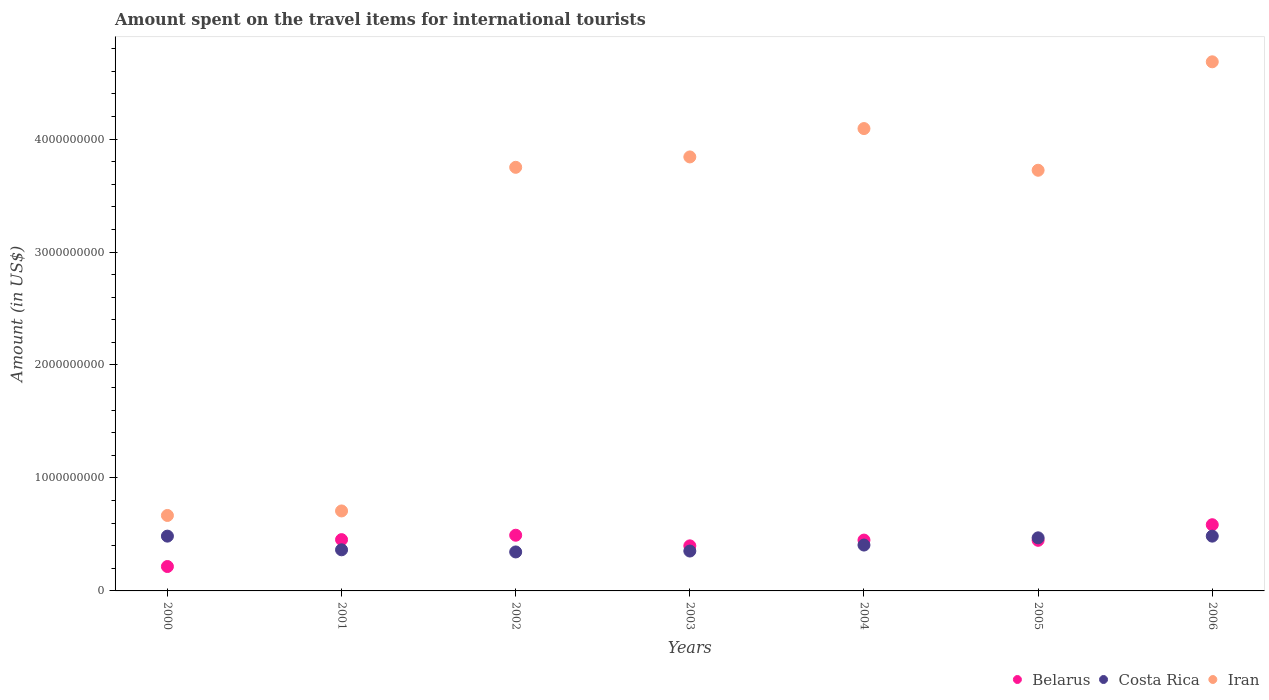How many different coloured dotlines are there?
Keep it short and to the point. 3. What is the amount spent on the travel items for international tourists in Belarus in 2006?
Ensure brevity in your answer.  5.86e+08. Across all years, what is the maximum amount spent on the travel items for international tourists in Belarus?
Your answer should be very brief. 5.86e+08. Across all years, what is the minimum amount spent on the travel items for international tourists in Belarus?
Give a very brief answer. 2.16e+08. In which year was the amount spent on the travel items for international tourists in Iran minimum?
Give a very brief answer. 2000. What is the total amount spent on the travel items for international tourists in Belarus in the graph?
Make the answer very short. 3.05e+09. What is the difference between the amount spent on the travel items for international tourists in Belarus in 2002 and that in 2004?
Offer a terse response. 4.30e+07. What is the difference between the amount spent on the travel items for international tourists in Iran in 2004 and the amount spent on the travel items for international tourists in Belarus in 2002?
Offer a terse response. 3.60e+09. What is the average amount spent on the travel items for international tourists in Costa Rica per year?
Keep it short and to the point. 4.15e+08. In the year 2002, what is the difference between the amount spent on the travel items for international tourists in Belarus and amount spent on the travel items for international tourists in Costa Rica?
Make the answer very short. 1.48e+08. In how many years, is the amount spent on the travel items for international tourists in Costa Rica greater than 2200000000 US$?
Your answer should be very brief. 0. What is the ratio of the amount spent on the travel items for international tourists in Costa Rica in 2001 to that in 2005?
Provide a succinct answer. 0.77. Is the difference between the amount spent on the travel items for international tourists in Belarus in 2000 and 2006 greater than the difference between the amount spent on the travel items for international tourists in Costa Rica in 2000 and 2006?
Make the answer very short. No. What is the difference between the highest and the second highest amount spent on the travel items for international tourists in Iran?
Keep it short and to the point. 5.91e+08. What is the difference between the highest and the lowest amount spent on the travel items for international tourists in Belarus?
Provide a succinct answer. 3.70e+08. In how many years, is the amount spent on the travel items for international tourists in Iran greater than the average amount spent on the travel items for international tourists in Iran taken over all years?
Provide a succinct answer. 5. Is the amount spent on the travel items for international tourists in Belarus strictly greater than the amount spent on the travel items for international tourists in Iran over the years?
Ensure brevity in your answer.  No. Is the amount spent on the travel items for international tourists in Belarus strictly less than the amount spent on the travel items for international tourists in Costa Rica over the years?
Provide a succinct answer. No. How many dotlines are there?
Offer a terse response. 3. What is the difference between two consecutive major ticks on the Y-axis?
Your answer should be very brief. 1.00e+09. Are the values on the major ticks of Y-axis written in scientific E-notation?
Provide a short and direct response. No. Does the graph contain any zero values?
Your response must be concise. No. Does the graph contain grids?
Give a very brief answer. No. How many legend labels are there?
Your answer should be very brief. 3. What is the title of the graph?
Provide a succinct answer. Amount spent on the travel items for international tourists. What is the label or title of the Y-axis?
Provide a succinct answer. Amount (in US$). What is the Amount (in US$) in Belarus in 2000?
Your answer should be compact. 2.16e+08. What is the Amount (in US$) in Costa Rica in 2000?
Your response must be concise. 4.85e+08. What is the Amount (in US$) of Iran in 2000?
Your answer should be very brief. 6.68e+08. What is the Amount (in US$) of Belarus in 2001?
Offer a terse response. 4.54e+08. What is the Amount (in US$) of Costa Rica in 2001?
Keep it short and to the point. 3.64e+08. What is the Amount (in US$) in Iran in 2001?
Offer a terse response. 7.08e+08. What is the Amount (in US$) in Belarus in 2002?
Provide a succinct answer. 4.93e+08. What is the Amount (in US$) of Costa Rica in 2002?
Make the answer very short. 3.45e+08. What is the Amount (in US$) of Iran in 2002?
Offer a terse response. 3.75e+09. What is the Amount (in US$) of Belarus in 2003?
Your answer should be very brief. 3.99e+08. What is the Amount (in US$) in Costa Rica in 2003?
Keep it short and to the point. 3.53e+08. What is the Amount (in US$) in Iran in 2003?
Your response must be concise. 3.84e+09. What is the Amount (in US$) in Belarus in 2004?
Make the answer very short. 4.50e+08. What is the Amount (in US$) of Costa Rica in 2004?
Provide a short and direct response. 4.06e+08. What is the Amount (in US$) in Iran in 2004?
Provide a succinct answer. 4.09e+09. What is the Amount (in US$) in Belarus in 2005?
Your response must be concise. 4.48e+08. What is the Amount (in US$) of Costa Rica in 2005?
Your answer should be compact. 4.70e+08. What is the Amount (in US$) of Iran in 2005?
Keep it short and to the point. 3.72e+09. What is the Amount (in US$) in Belarus in 2006?
Give a very brief answer. 5.86e+08. What is the Amount (in US$) of Costa Rica in 2006?
Give a very brief answer. 4.85e+08. What is the Amount (in US$) in Iran in 2006?
Make the answer very short. 4.68e+09. Across all years, what is the maximum Amount (in US$) in Belarus?
Give a very brief answer. 5.86e+08. Across all years, what is the maximum Amount (in US$) of Costa Rica?
Provide a short and direct response. 4.85e+08. Across all years, what is the maximum Amount (in US$) of Iran?
Provide a short and direct response. 4.68e+09. Across all years, what is the minimum Amount (in US$) of Belarus?
Your answer should be compact. 2.16e+08. Across all years, what is the minimum Amount (in US$) of Costa Rica?
Make the answer very short. 3.45e+08. Across all years, what is the minimum Amount (in US$) of Iran?
Your answer should be very brief. 6.68e+08. What is the total Amount (in US$) of Belarus in the graph?
Ensure brevity in your answer.  3.05e+09. What is the total Amount (in US$) of Costa Rica in the graph?
Ensure brevity in your answer.  2.91e+09. What is the total Amount (in US$) in Iran in the graph?
Offer a terse response. 2.15e+1. What is the difference between the Amount (in US$) in Belarus in 2000 and that in 2001?
Your answer should be very brief. -2.38e+08. What is the difference between the Amount (in US$) of Costa Rica in 2000 and that in 2001?
Offer a very short reply. 1.21e+08. What is the difference between the Amount (in US$) in Iran in 2000 and that in 2001?
Make the answer very short. -4.00e+07. What is the difference between the Amount (in US$) in Belarus in 2000 and that in 2002?
Provide a short and direct response. -2.77e+08. What is the difference between the Amount (in US$) in Costa Rica in 2000 and that in 2002?
Your response must be concise. 1.40e+08. What is the difference between the Amount (in US$) of Iran in 2000 and that in 2002?
Offer a terse response. -3.08e+09. What is the difference between the Amount (in US$) of Belarus in 2000 and that in 2003?
Provide a succinct answer. -1.83e+08. What is the difference between the Amount (in US$) of Costa Rica in 2000 and that in 2003?
Make the answer very short. 1.32e+08. What is the difference between the Amount (in US$) of Iran in 2000 and that in 2003?
Give a very brief answer. -3.17e+09. What is the difference between the Amount (in US$) of Belarus in 2000 and that in 2004?
Give a very brief answer. -2.34e+08. What is the difference between the Amount (in US$) in Costa Rica in 2000 and that in 2004?
Give a very brief answer. 7.90e+07. What is the difference between the Amount (in US$) of Iran in 2000 and that in 2004?
Make the answer very short. -3.42e+09. What is the difference between the Amount (in US$) of Belarus in 2000 and that in 2005?
Provide a succinct answer. -2.32e+08. What is the difference between the Amount (in US$) in Costa Rica in 2000 and that in 2005?
Ensure brevity in your answer.  1.50e+07. What is the difference between the Amount (in US$) of Iran in 2000 and that in 2005?
Keep it short and to the point. -3.06e+09. What is the difference between the Amount (in US$) in Belarus in 2000 and that in 2006?
Keep it short and to the point. -3.70e+08. What is the difference between the Amount (in US$) in Costa Rica in 2000 and that in 2006?
Keep it short and to the point. 0. What is the difference between the Amount (in US$) in Iran in 2000 and that in 2006?
Offer a terse response. -4.02e+09. What is the difference between the Amount (in US$) of Belarus in 2001 and that in 2002?
Your answer should be compact. -3.90e+07. What is the difference between the Amount (in US$) of Costa Rica in 2001 and that in 2002?
Make the answer very short. 1.90e+07. What is the difference between the Amount (in US$) in Iran in 2001 and that in 2002?
Give a very brief answer. -3.04e+09. What is the difference between the Amount (in US$) of Belarus in 2001 and that in 2003?
Your answer should be very brief. 5.50e+07. What is the difference between the Amount (in US$) in Costa Rica in 2001 and that in 2003?
Keep it short and to the point. 1.10e+07. What is the difference between the Amount (in US$) of Iran in 2001 and that in 2003?
Keep it short and to the point. -3.13e+09. What is the difference between the Amount (in US$) in Costa Rica in 2001 and that in 2004?
Provide a succinct answer. -4.20e+07. What is the difference between the Amount (in US$) in Iran in 2001 and that in 2004?
Your response must be concise. -3.38e+09. What is the difference between the Amount (in US$) of Belarus in 2001 and that in 2005?
Offer a very short reply. 6.00e+06. What is the difference between the Amount (in US$) of Costa Rica in 2001 and that in 2005?
Make the answer very short. -1.06e+08. What is the difference between the Amount (in US$) in Iran in 2001 and that in 2005?
Offer a very short reply. -3.02e+09. What is the difference between the Amount (in US$) of Belarus in 2001 and that in 2006?
Offer a terse response. -1.32e+08. What is the difference between the Amount (in US$) in Costa Rica in 2001 and that in 2006?
Make the answer very short. -1.21e+08. What is the difference between the Amount (in US$) of Iran in 2001 and that in 2006?
Make the answer very short. -3.98e+09. What is the difference between the Amount (in US$) in Belarus in 2002 and that in 2003?
Provide a short and direct response. 9.40e+07. What is the difference between the Amount (in US$) in Costa Rica in 2002 and that in 2003?
Offer a terse response. -8.00e+06. What is the difference between the Amount (in US$) in Iran in 2002 and that in 2003?
Ensure brevity in your answer.  -9.20e+07. What is the difference between the Amount (in US$) in Belarus in 2002 and that in 2004?
Your answer should be compact. 4.30e+07. What is the difference between the Amount (in US$) of Costa Rica in 2002 and that in 2004?
Your answer should be very brief. -6.10e+07. What is the difference between the Amount (in US$) of Iran in 2002 and that in 2004?
Ensure brevity in your answer.  -3.43e+08. What is the difference between the Amount (in US$) of Belarus in 2002 and that in 2005?
Ensure brevity in your answer.  4.50e+07. What is the difference between the Amount (in US$) in Costa Rica in 2002 and that in 2005?
Provide a short and direct response. -1.25e+08. What is the difference between the Amount (in US$) in Iran in 2002 and that in 2005?
Your answer should be very brief. 2.60e+07. What is the difference between the Amount (in US$) of Belarus in 2002 and that in 2006?
Give a very brief answer. -9.30e+07. What is the difference between the Amount (in US$) of Costa Rica in 2002 and that in 2006?
Make the answer very short. -1.40e+08. What is the difference between the Amount (in US$) in Iran in 2002 and that in 2006?
Give a very brief answer. -9.34e+08. What is the difference between the Amount (in US$) of Belarus in 2003 and that in 2004?
Your response must be concise. -5.10e+07. What is the difference between the Amount (in US$) of Costa Rica in 2003 and that in 2004?
Your response must be concise. -5.30e+07. What is the difference between the Amount (in US$) of Iran in 2003 and that in 2004?
Provide a short and direct response. -2.51e+08. What is the difference between the Amount (in US$) in Belarus in 2003 and that in 2005?
Provide a short and direct response. -4.90e+07. What is the difference between the Amount (in US$) in Costa Rica in 2003 and that in 2005?
Provide a short and direct response. -1.17e+08. What is the difference between the Amount (in US$) in Iran in 2003 and that in 2005?
Keep it short and to the point. 1.18e+08. What is the difference between the Amount (in US$) in Belarus in 2003 and that in 2006?
Provide a succinct answer. -1.87e+08. What is the difference between the Amount (in US$) of Costa Rica in 2003 and that in 2006?
Your response must be concise. -1.32e+08. What is the difference between the Amount (in US$) in Iran in 2003 and that in 2006?
Offer a terse response. -8.42e+08. What is the difference between the Amount (in US$) in Belarus in 2004 and that in 2005?
Your response must be concise. 2.00e+06. What is the difference between the Amount (in US$) in Costa Rica in 2004 and that in 2005?
Your answer should be compact. -6.40e+07. What is the difference between the Amount (in US$) in Iran in 2004 and that in 2005?
Provide a short and direct response. 3.69e+08. What is the difference between the Amount (in US$) in Belarus in 2004 and that in 2006?
Keep it short and to the point. -1.36e+08. What is the difference between the Amount (in US$) in Costa Rica in 2004 and that in 2006?
Keep it short and to the point. -7.90e+07. What is the difference between the Amount (in US$) of Iran in 2004 and that in 2006?
Your answer should be compact. -5.91e+08. What is the difference between the Amount (in US$) of Belarus in 2005 and that in 2006?
Your answer should be compact. -1.38e+08. What is the difference between the Amount (in US$) of Costa Rica in 2005 and that in 2006?
Your answer should be very brief. -1.50e+07. What is the difference between the Amount (in US$) in Iran in 2005 and that in 2006?
Give a very brief answer. -9.60e+08. What is the difference between the Amount (in US$) of Belarus in 2000 and the Amount (in US$) of Costa Rica in 2001?
Keep it short and to the point. -1.48e+08. What is the difference between the Amount (in US$) in Belarus in 2000 and the Amount (in US$) in Iran in 2001?
Your answer should be compact. -4.92e+08. What is the difference between the Amount (in US$) of Costa Rica in 2000 and the Amount (in US$) of Iran in 2001?
Your response must be concise. -2.23e+08. What is the difference between the Amount (in US$) in Belarus in 2000 and the Amount (in US$) in Costa Rica in 2002?
Ensure brevity in your answer.  -1.29e+08. What is the difference between the Amount (in US$) of Belarus in 2000 and the Amount (in US$) of Iran in 2002?
Provide a short and direct response. -3.53e+09. What is the difference between the Amount (in US$) in Costa Rica in 2000 and the Amount (in US$) in Iran in 2002?
Offer a very short reply. -3.26e+09. What is the difference between the Amount (in US$) of Belarus in 2000 and the Amount (in US$) of Costa Rica in 2003?
Your response must be concise. -1.37e+08. What is the difference between the Amount (in US$) of Belarus in 2000 and the Amount (in US$) of Iran in 2003?
Provide a short and direct response. -3.63e+09. What is the difference between the Amount (in US$) in Costa Rica in 2000 and the Amount (in US$) in Iran in 2003?
Your answer should be compact. -3.36e+09. What is the difference between the Amount (in US$) of Belarus in 2000 and the Amount (in US$) of Costa Rica in 2004?
Your response must be concise. -1.90e+08. What is the difference between the Amount (in US$) in Belarus in 2000 and the Amount (in US$) in Iran in 2004?
Make the answer very short. -3.88e+09. What is the difference between the Amount (in US$) in Costa Rica in 2000 and the Amount (in US$) in Iran in 2004?
Make the answer very short. -3.61e+09. What is the difference between the Amount (in US$) of Belarus in 2000 and the Amount (in US$) of Costa Rica in 2005?
Your response must be concise. -2.54e+08. What is the difference between the Amount (in US$) in Belarus in 2000 and the Amount (in US$) in Iran in 2005?
Your answer should be compact. -3.51e+09. What is the difference between the Amount (in US$) in Costa Rica in 2000 and the Amount (in US$) in Iran in 2005?
Offer a terse response. -3.24e+09. What is the difference between the Amount (in US$) of Belarus in 2000 and the Amount (in US$) of Costa Rica in 2006?
Your answer should be compact. -2.69e+08. What is the difference between the Amount (in US$) of Belarus in 2000 and the Amount (in US$) of Iran in 2006?
Offer a very short reply. -4.47e+09. What is the difference between the Amount (in US$) of Costa Rica in 2000 and the Amount (in US$) of Iran in 2006?
Offer a terse response. -4.20e+09. What is the difference between the Amount (in US$) of Belarus in 2001 and the Amount (in US$) of Costa Rica in 2002?
Your answer should be compact. 1.09e+08. What is the difference between the Amount (in US$) of Belarus in 2001 and the Amount (in US$) of Iran in 2002?
Provide a succinct answer. -3.30e+09. What is the difference between the Amount (in US$) of Costa Rica in 2001 and the Amount (in US$) of Iran in 2002?
Keep it short and to the point. -3.39e+09. What is the difference between the Amount (in US$) in Belarus in 2001 and the Amount (in US$) in Costa Rica in 2003?
Provide a succinct answer. 1.01e+08. What is the difference between the Amount (in US$) in Belarus in 2001 and the Amount (in US$) in Iran in 2003?
Give a very brief answer. -3.39e+09. What is the difference between the Amount (in US$) in Costa Rica in 2001 and the Amount (in US$) in Iran in 2003?
Keep it short and to the point. -3.48e+09. What is the difference between the Amount (in US$) of Belarus in 2001 and the Amount (in US$) of Costa Rica in 2004?
Provide a short and direct response. 4.80e+07. What is the difference between the Amount (in US$) in Belarus in 2001 and the Amount (in US$) in Iran in 2004?
Give a very brief answer. -3.64e+09. What is the difference between the Amount (in US$) of Costa Rica in 2001 and the Amount (in US$) of Iran in 2004?
Your answer should be compact. -3.73e+09. What is the difference between the Amount (in US$) of Belarus in 2001 and the Amount (in US$) of Costa Rica in 2005?
Provide a short and direct response. -1.60e+07. What is the difference between the Amount (in US$) in Belarus in 2001 and the Amount (in US$) in Iran in 2005?
Give a very brief answer. -3.27e+09. What is the difference between the Amount (in US$) in Costa Rica in 2001 and the Amount (in US$) in Iran in 2005?
Make the answer very short. -3.36e+09. What is the difference between the Amount (in US$) in Belarus in 2001 and the Amount (in US$) in Costa Rica in 2006?
Your response must be concise. -3.10e+07. What is the difference between the Amount (in US$) in Belarus in 2001 and the Amount (in US$) in Iran in 2006?
Provide a short and direct response. -4.23e+09. What is the difference between the Amount (in US$) of Costa Rica in 2001 and the Amount (in US$) of Iran in 2006?
Provide a short and direct response. -4.32e+09. What is the difference between the Amount (in US$) of Belarus in 2002 and the Amount (in US$) of Costa Rica in 2003?
Your response must be concise. 1.40e+08. What is the difference between the Amount (in US$) in Belarus in 2002 and the Amount (in US$) in Iran in 2003?
Give a very brief answer. -3.35e+09. What is the difference between the Amount (in US$) in Costa Rica in 2002 and the Amount (in US$) in Iran in 2003?
Offer a terse response. -3.50e+09. What is the difference between the Amount (in US$) in Belarus in 2002 and the Amount (in US$) in Costa Rica in 2004?
Keep it short and to the point. 8.70e+07. What is the difference between the Amount (in US$) in Belarus in 2002 and the Amount (in US$) in Iran in 2004?
Your response must be concise. -3.60e+09. What is the difference between the Amount (in US$) in Costa Rica in 2002 and the Amount (in US$) in Iran in 2004?
Ensure brevity in your answer.  -3.75e+09. What is the difference between the Amount (in US$) in Belarus in 2002 and the Amount (in US$) in Costa Rica in 2005?
Make the answer very short. 2.30e+07. What is the difference between the Amount (in US$) of Belarus in 2002 and the Amount (in US$) of Iran in 2005?
Give a very brief answer. -3.23e+09. What is the difference between the Amount (in US$) of Costa Rica in 2002 and the Amount (in US$) of Iran in 2005?
Provide a short and direct response. -3.38e+09. What is the difference between the Amount (in US$) in Belarus in 2002 and the Amount (in US$) in Costa Rica in 2006?
Offer a very short reply. 8.00e+06. What is the difference between the Amount (in US$) of Belarus in 2002 and the Amount (in US$) of Iran in 2006?
Provide a short and direct response. -4.19e+09. What is the difference between the Amount (in US$) of Costa Rica in 2002 and the Amount (in US$) of Iran in 2006?
Provide a succinct answer. -4.34e+09. What is the difference between the Amount (in US$) of Belarus in 2003 and the Amount (in US$) of Costa Rica in 2004?
Your answer should be very brief. -7.00e+06. What is the difference between the Amount (in US$) in Belarus in 2003 and the Amount (in US$) in Iran in 2004?
Offer a very short reply. -3.69e+09. What is the difference between the Amount (in US$) of Costa Rica in 2003 and the Amount (in US$) of Iran in 2004?
Your response must be concise. -3.74e+09. What is the difference between the Amount (in US$) of Belarus in 2003 and the Amount (in US$) of Costa Rica in 2005?
Make the answer very short. -7.10e+07. What is the difference between the Amount (in US$) of Belarus in 2003 and the Amount (in US$) of Iran in 2005?
Ensure brevity in your answer.  -3.32e+09. What is the difference between the Amount (in US$) in Costa Rica in 2003 and the Amount (in US$) in Iran in 2005?
Make the answer very short. -3.37e+09. What is the difference between the Amount (in US$) of Belarus in 2003 and the Amount (in US$) of Costa Rica in 2006?
Keep it short and to the point. -8.60e+07. What is the difference between the Amount (in US$) of Belarus in 2003 and the Amount (in US$) of Iran in 2006?
Your response must be concise. -4.28e+09. What is the difference between the Amount (in US$) in Costa Rica in 2003 and the Amount (in US$) in Iran in 2006?
Your response must be concise. -4.33e+09. What is the difference between the Amount (in US$) in Belarus in 2004 and the Amount (in US$) in Costa Rica in 2005?
Make the answer very short. -2.00e+07. What is the difference between the Amount (in US$) of Belarus in 2004 and the Amount (in US$) of Iran in 2005?
Your response must be concise. -3.27e+09. What is the difference between the Amount (in US$) in Costa Rica in 2004 and the Amount (in US$) in Iran in 2005?
Give a very brief answer. -3.32e+09. What is the difference between the Amount (in US$) in Belarus in 2004 and the Amount (in US$) in Costa Rica in 2006?
Ensure brevity in your answer.  -3.50e+07. What is the difference between the Amount (in US$) of Belarus in 2004 and the Amount (in US$) of Iran in 2006?
Your answer should be compact. -4.23e+09. What is the difference between the Amount (in US$) in Costa Rica in 2004 and the Amount (in US$) in Iran in 2006?
Your response must be concise. -4.28e+09. What is the difference between the Amount (in US$) of Belarus in 2005 and the Amount (in US$) of Costa Rica in 2006?
Ensure brevity in your answer.  -3.70e+07. What is the difference between the Amount (in US$) in Belarus in 2005 and the Amount (in US$) in Iran in 2006?
Keep it short and to the point. -4.24e+09. What is the difference between the Amount (in US$) in Costa Rica in 2005 and the Amount (in US$) in Iran in 2006?
Keep it short and to the point. -4.21e+09. What is the average Amount (in US$) in Belarus per year?
Provide a succinct answer. 4.35e+08. What is the average Amount (in US$) of Costa Rica per year?
Offer a terse response. 4.15e+08. What is the average Amount (in US$) of Iran per year?
Make the answer very short. 3.07e+09. In the year 2000, what is the difference between the Amount (in US$) in Belarus and Amount (in US$) in Costa Rica?
Keep it short and to the point. -2.69e+08. In the year 2000, what is the difference between the Amount (in US$) in Belarus and Amount (in US$) in Iran?
Provide a succinct answer. -4.52e+08. In the year 2000, what is the difference between the Amount (in US$) in Costa Rica and Amount (in US$) in Iran?
Keep it short and to the point. -1.83e+08. In the year 2001, what is the difference between the Amount (in US$) of Belarus and Amount (in US$) of Costa Rica?
Your answer should be very brief. 9.00e+07. In the year 2001, what is the difference between the Amount (in US$) in Belarus and Amount (in US$) in Iran?
Keep it short and to the point. -2.54e+08. In the year 2001, what is the difference between the Amount (in US$) of Costa Rica and Amount (in US$) of Iran?
Ensure brevity in your answer.  -3.44e+08. In the year 2002, what is the difference between the Amount (in US$) of Belarus and Amount (in US$) of Costa Rica?
Ensure brevity in your answer.  1.48e+08. In the year 2002, what is the difference between the Amount (in US$) in Belarus and Amount (in US$) in Iran?
Ensure brevity in your answer.  -3.26e+09. In the year 2002, what is the difference between the Amount (in US$) in Costa Rica and Amount (in US$) in Iran?
Your answer should be very brief. -3.40e+09. In the year 2003, what is the difference between the Amount (in US$) in Belarus and Amount (in US$) in Costa Rica?
Ensure brevity in your answer.  4.60e+07. In the year 2003, what is the difference between the Amount (in US$) in Belarus and Amount (in US$) in Iran?
Provide a succinct answer. -3.44e+09. In the year 2003, what is the difference between the Amount (in US$) in Costa Rica and Amount (in US$) in Iran?
Ensure brevity in your answer.  -3.49e+09. In the year 2004, what is the difference between the Amount (in US$) of Belarus and Amount (in US$) of Costa Rica?
Provide a succinct answer. 4.40e+07. In the year 2004, what is the difference between the Amount (in US$) in Belarus and Amount (in US$) in Iran?
Offer a terse response. -3.64e+09. In the year 2004, what is the difference between the Amount (in US$) in Costa Rica and Amount (in US$) in Iran?
Offer a very short reply. -3.69e+09. In the year 2005, what is the difference between the Amount (in US$) of Belarus and Amount (in US$) of Costa Rica?
Provide a short and direct response. -2.20e+07. In the year 2005, what is the difference between the Amount (in US$) of Belarus and Amount (in US$) of Iran?
Offer a terse response. -3.28e+09. In the year 2005, what is the difference between the Amount (in US$) in Costa Rica and Amount (in US$) in Iran?
Provide a short and direct response. -3.25e+09. In the year 2006, what is the difference between the Amount (in US$) of Belarus and Amount (in US$) of Costa Rica?
Offer a terse response. 1.01e+08. In the year 2006, what is the difference between the Amount (in US$) in Belarus and Amount (in US$) in Iran?
Make the answer very short. -4.10e+09. In the year 2006, what is the difference between the Amount (in US$) in Costa Rica and Amount (in US$) in Iran?
Keep it short and to the point. -4.20e+09. What is the ratio of the Amount (in US$) in Belarus in 2000 to that in 2001?
Keep it short and to the point. 0.48. What is the ratio of the Amount (in US$) of Costa Rica in 2000 to that in 2001?
Your response must be concise. 1.33. What is the ratio of the Amount (in US$) of Iran in 2000 to that in 2001?
Offer a terse response. 0.94. What is the ratio of the Amount (in US$) of Belarus in 2000 to that in 2002?
Your response must be concise. 0.44. What is the ratio of the Amount (in US$) in Costa Rica in 2000 to that in 2002?
Make the answer very short. 1.41. What is the ratio of the Amount (in US$) of Iran in 2000 to that in 2002?
Your answer should be compact. 0.18. What is the ratio of the Amount (in US$) of Belarus in 2000 to that in 2003?
Provide a short and direct response. 0.54. What is the ratio of the Amount (in US$) in Costa Rica in 2000 to that in 2003?
Provide a succinct answer. 1.37. What is the ratio of the Amount (in US$) in Iran in 2000 to that in 2003?
Give a very brief answer. 0.17. What is the ratio of the Amount (in US$) in Belarus in 2000 to that in 2004?
Make the answer very short. 0.48. What is the ratio of the Amount (in US$) in Costa Rica in 2000 to that in 2004?
Offer a terse response. 1.19. What is the ratio of the Amount (in US$) in Iran in 2000 to that in 2004?
Ensure brevity in your answer.  0.16. What is the ratio of the Amount (in US$) of Belarus in 2000 to that in 2005?
Keep it short and to the point. 0.48. What is the ratio of the Amount (in US$) in Costa Rica in 2000 to that in 2005?
Your answer should be compact. 1.03. What is the ratio of the Amount (in US$) of Iran in 2000 to that in 2005?
Offer a very short reply. 0.18. What is the ratio of the Amount (in US$) in Belarus in 2000 to that in 2006?
Your answer should be compact. 0.37. What is the ratio of the Amount (in US$) of Iran in 2000 to that in 2006?
Your answer should be compact. 0.14. What is the ratio of the Amount (in US$) in Belarus in 2001 to that in 2002?
Give a very brief answer. 0.92. What is the ratio of the Amount (in US$) in Costa Rica in 2001 to that in 2002?
Provide a succinct answer. 1.06. What is the ratio of the Amount (in US$) of Iran in 2001 to that in 2002?
Provide a succinct answer. 0.19. What is the ratio of the Amount (in US$) of Belarus in 2001 to that in 2003?
Offer a very short reply. 1.14. What is the ratio of the Amount (in US$) of Costa Rica in 2001 to that in 2003?
Give a very brief answer. 1.03. What is the ratio of the Amount (in US$) in Iran in 2001 to that in 2003?
Provide a short and direct response. 0.18. What is the ratio of the Amount (in US$) in Belarus in 2001 to that in 2004?
Offer a very short reply. 1.01. What is the ratio of the Amount (in US$) of Costa Rica in 2001 to that in 2004?
Offer a very short reply. 0.9. What is the ratio of the Amount (in US$) of Iran in 2001 to that in 2004?
Keep it short and to the point. 0.17. What is the ratio of the Amount (in US$) of Belarus in 2001 to that in 2005?
Keep it short and to the point. 1.01. What is the ratio of the Amount (in US$) of Costa Rica in 2001 to that in 2005?
Give a very brief answer. 0.77. What is the ratio of the Amount (in US$) in Iran in 2001 to that in 2005?
Provide a short and direct response. 0.19. What is the ratio of the Amount (in US$) in Belarus in 2001 to that in 2006?
Your answer should be compact. 0.77. What is the ratio of the Amount (in US$) in Costa Rica in 2001 to that in 2006?
Your answer should be compact. 0.75. What is the ratio of the Amount (in US$) of Iran in 2001 to that in 2006?
Your answer should be compact. 0.15. What is the ratio of the Amount (in US$) of Belarus in 2002 to that in 2003?
Offer a terse response. 1.24. What is the ratio of the Amount (in US$) of Costa Rica in 2002 to that in 2003?
Your answer should be compact. 0.98. What is the ratio of the Amount (in US$) in Iran in 2002 to that in 2003?
Ensure brevity in your answer.  0.98. What is the ratio of the Amount (in US$) in Belarus in 2002 to that in 2004?
Keep it short and to the point. 1.1. What is the ratio of the Amount (in US$) in Costa Rica in 2002 to that in 2004?
Your response must be concise. 0.85. What is the ratio of the Amount (in US$) in Iran in 2002 to that in 2004?
Provide a short and direct response. 0.92. What is the ratio of the Amount (in US$) of Belarus in 2002 to that in 2005?
Keep it short and to the point. 1.1. What is the ratio of the Amount (in US$) in Costa Rica in 2002 to that in 2005?
Provide a succinct answer. 0.73. What is the ratio of the Amount (in US$) of Iran in 2002 to that in 2005?
Offer a terse response. 1.01. What is the ratio of the Amount (in US$) of Belarus in 2002 to that in 2006?
Your answer should be compact. 0.84. What is the ratio of the Amount (in US$) of Costa Rica in 2002 to that in 2006?
Offer a terse response. 0.71. What is the ratio of the Amount (in US$) in Iran in 2002 to that in 2006?
Give a very brief answer. 0.8. What is the ratio of the Amount (in US$) of Belarus in 2003 to that in 2004?
Your response must be concise. 0.89. What is the ratio of the Amount (in US$) of Costa Rica in 2003 to that in 2004?
Keep it short and to the point. 0.87. What is the ratio of the Amount (in US$) in Iran in 2003 to that in 2004?
Offer a terse response. 0.94. What is the ratio of the Amount (in US$) in Belarus in 2003 to that in 2005?
Offer a terse response. 0.89. What is the ratio of the Amount (in US$) in Costa Rica in 2003 to that in 2005?
Offer a terse response. 0.75. What is the ratio of the Amount (in US$) in Iran in 2003 to that in 2005?
Your answer should be very brief. 1.03. What is the ratio of the Amount (in US$) in Belarus in 2003 to that in 2006?
Offer a terse response. 0.68. What is the ratio of the Amount (in US$) of Costa Rica in 2003 to that in 2006?
Give a very brief answer. 0.73. What is the ratio of the Amount (in US$) of Iran in 2003 to that in 2006?
Offer a terse response. 0.82. What is the ratio of the Amount (in US$) in Belarus in 2004 to that in 2005?
Your answer should be compact. 1. What is the ratio of the Amount (in US$) in Costa Rica in 2004 to that in 2005?
Provide a succinct answer. 0.86. What is the ratio of the Amount (in US$) of Iran in 2004 to that in 2005?
Ensure brevity in your answer.  1.1. What is the ratio of the Amount (in US$) in Belarus in 2004 to that in 2006?
Provide a short and direct response. 0.77. What is the ratio of the Amount (in US$) in Costa Rica in 2004 to that in 2006?
Keep it short and to the point. 0.84. What is the ratio of the Amount (in US$) in Iran in 2004 to that in 2006?
Keep it short and to the point. 0.87. What is the ratio of the Amount (in US$) in Belarus in 2005 to that in 2006?
Ensure brevity in your answer.  0.76. What is the ratio of the Amount (in US$) of Costa Rica in 2005 to that in 2006?
Make the answer very short. 0.97. What is the ratio of the Amount (in US$) of Iran in 2005 to that in 2006?
Make the answer very short. 0.8. What is the difference between the highest and the second highest Amount (in US$) in Belarus?
Provide a short and direct response. 9.30e+07. What is the difference between the highest and the second highest Amount (in US$) in Iran?
Your response must be concise. 5.91e+08. What is the difference between the highest and the lowest Amount (in US$) of Belarus?
Make the answer very short. 3.70e+08. What is the difference between the highest and the lowest Amount (in US$) of Costa Rica?
Give a very brief answer. 1.40e+08. What is the difference between the highest and the lowest Amount (in US$) of Iran?
Offer a very short reply. 4.02e+09. 